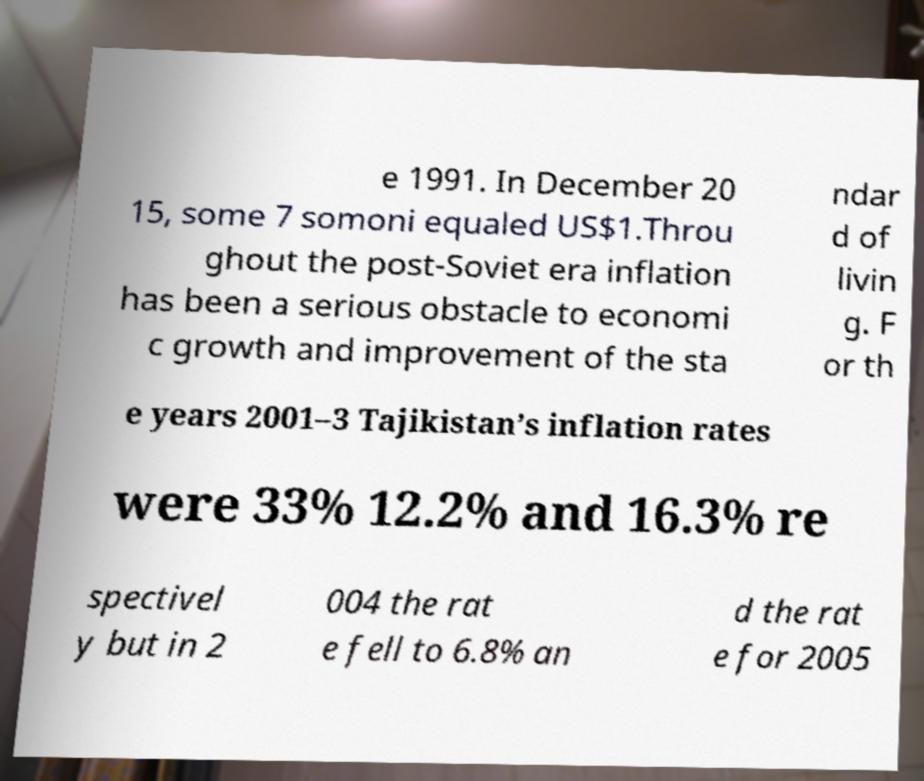Please read and relay the text visible in this image. What does it say? e 1991. In December 20 15, some 7 somoni equaled US$1.Throu ghout the post-Soviet era inflation has been a serious obstacle to economi c growth and improvement of the sta ndar d of livin g. F or th e years 2001–3 Tajikistan’s inflation rates were 33% 12.2% and 16.3% re spectivel y but in 2 004 the rat e fell to 6.8% an d the rat e for 2005 